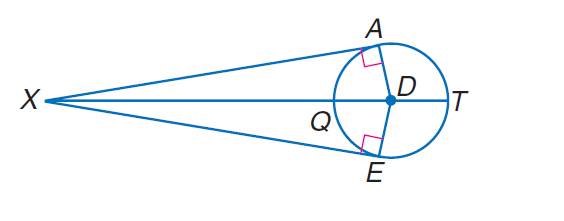Answer the mathemtical geometry problem and directly provide the correct option letter.
Question: Find Q X if E X = 24 and D E = 7.
Choices: A: 7 B: 18 C: 24 D: 25 B 